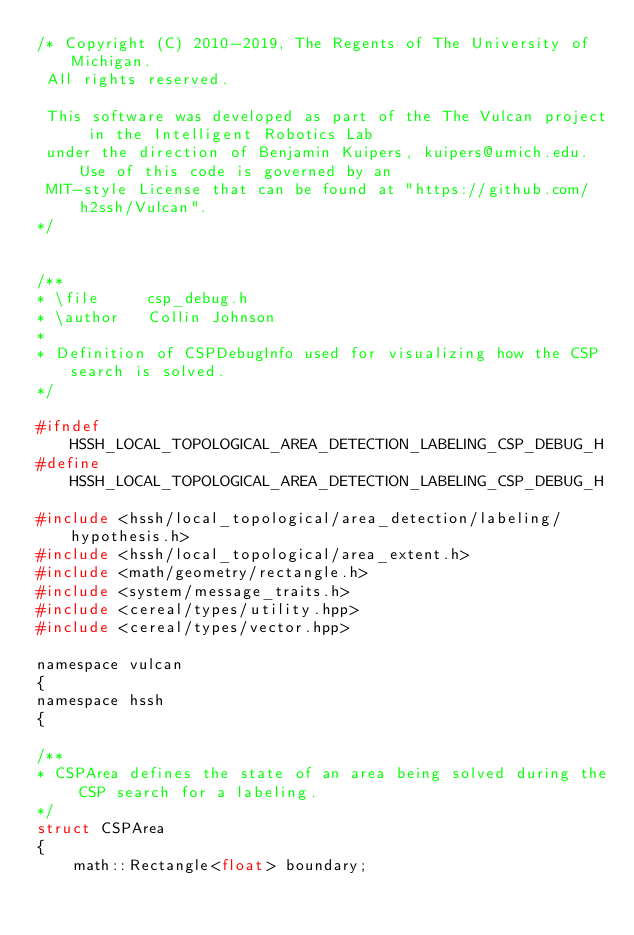Convert code to text. <code><loc_0><loc_0><loc_500><loc_500><_C_>/* Copyright (C) 2010-2019, The Regents of The University of Michigan.
 All rights reserved.

 This software was developed as part of the The Vulcan project in the Intelligent Robotics Lab
 under the direction of Benjamin Kuipers, kuipers@umich.edu. Use of this code is governed by an
 MIT-style License that can be found at "https://github.com/h2ssh/Vulcan".
*/


/**
* \file     csp_debug.h
* \author   Collin Johnson
*
* Definition of CSPDebugInfo used for visualizing how the CSP search is solved.
*/

#ifndef HSSH_LOCAL_TOPOLOGICAL_AREA_DETECTION_LABELING_CSP_DEBUG_H
#define HSSH_LOCAL_TOPOLOGICAL_AREA_DETECTION_LABELING_CSP_DEBUG_H

#include <hssh/local_topological/area_detection/labeling/hypothesis.h>
#include <hssh/local_topological/area_extent.h>
#include <math/geometry/rectangle.h>
#include <system/message_traits.h>
#include <cereal/types/utility.hpp>
#include <cereal/types/vector.hpp>

namespace vulcan
{
namespace hssh
{

/**
* CSPArea defines the state of an area being solved during the CSP search for a labeling.
*/
struct CSPArea
{
    math::Rectangle<float> boundary;</code> 